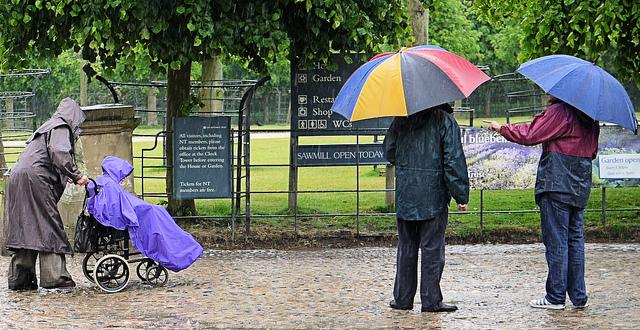What is the purple outfit the woman is wearing called? poncho 